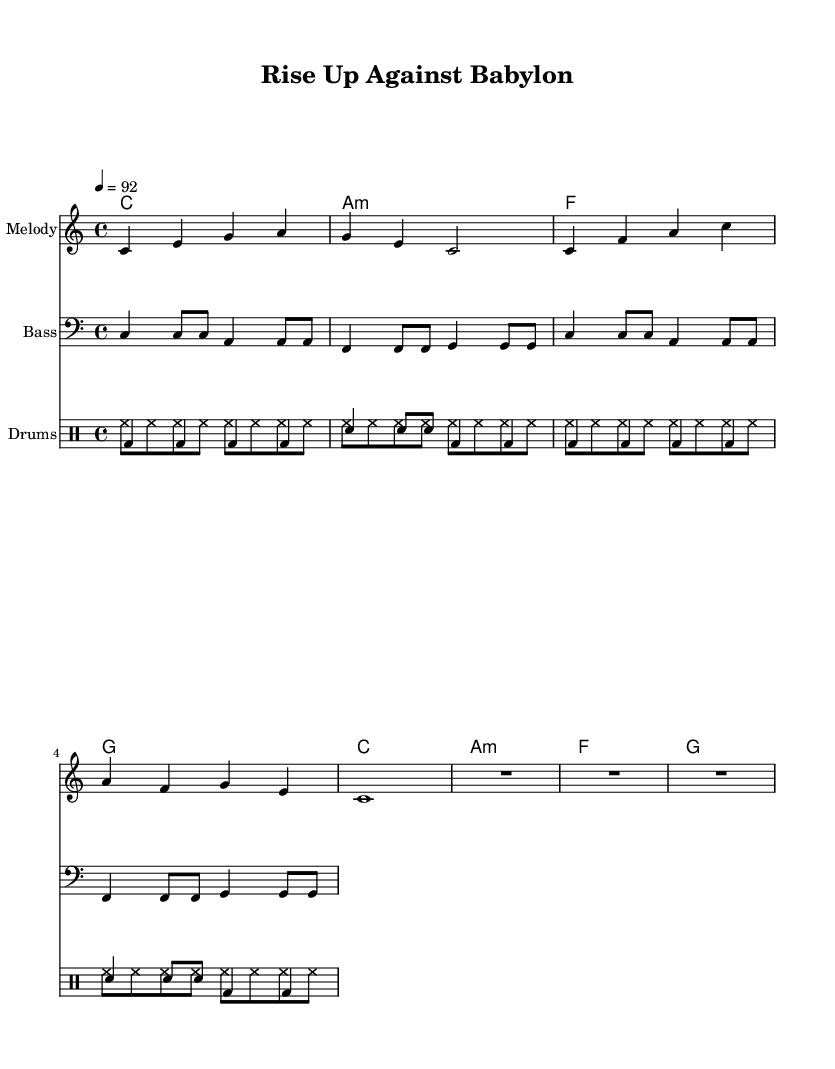What is the key signature of this music? The key signature is C major, which has no sharps or flats.
Answer: C major What is the time signature of the piece? The time signature is indicated as 4/4, meaning there are four beats in each measure.
Answer: 4/4 What is the tempo marking for this piece? The tempo marking is given as a metronome mark of 92 beats per minute, indicating the speed of the piece.
Answer: 92 How many measures are indicated in the melody? By counting the individual measures in the melody section, we find there are a total of 8 measures.
Answer: 8 What is the primary theme of the lyrics? The lyrics focus on the theme of resistance against oppression, emphasizing breaking free from chains.
Answer: Freedom What chord is used at the beginning of the harmony? The first chord in the harmony section is a C major chord, as notated in the chord names.
Answer: C What type of rhythm does the bass line primarily use? The bass line primarily uses a consistent quarter and eighth note rhythm throughout the piece.
Answer: Quarter and eighth notes 